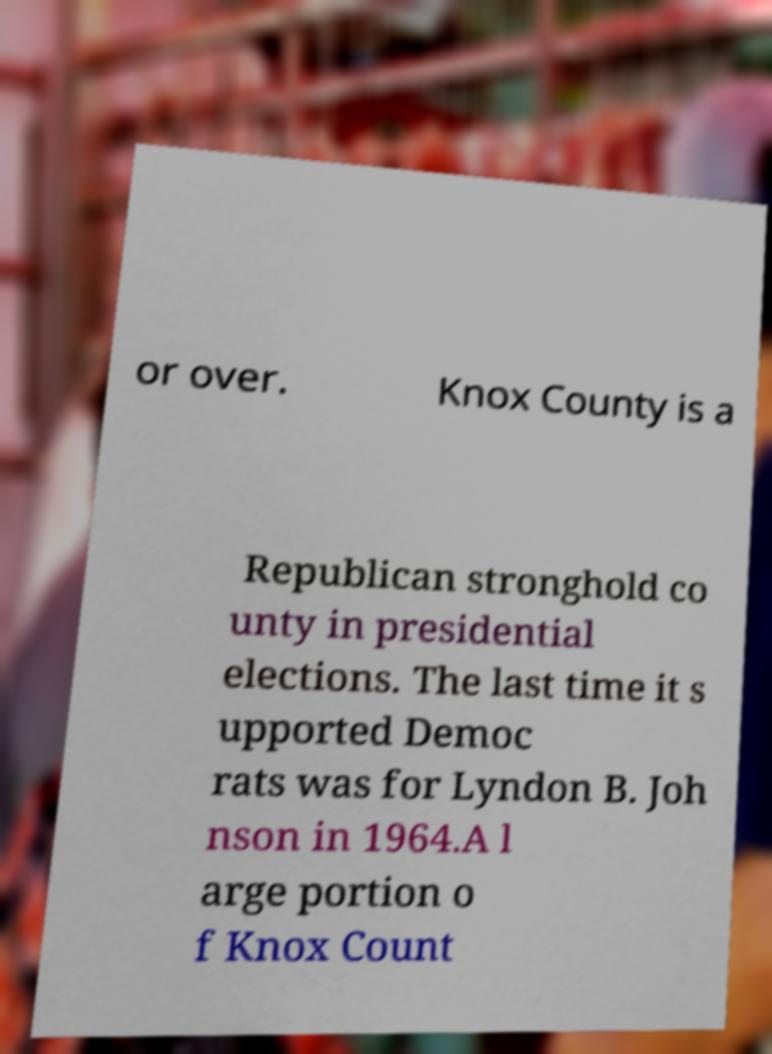Please read and relay the text visible in this image. What does it say? or over. Knox County is a Republican stronghold co unty in presidential elections. The last time it s upported Democ rats was for Lyndon B. Joh nson in 1964.A l arge portion o f Knox Count 